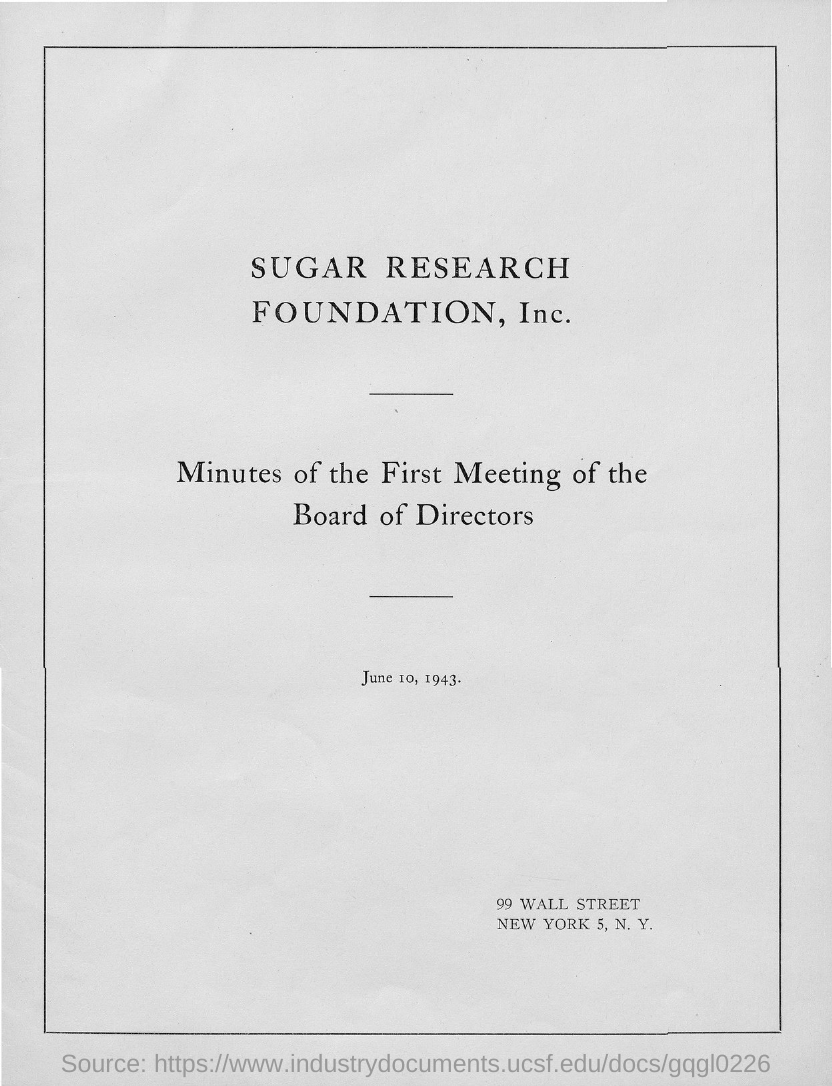What is the name of the foundation given at the top?
Give a very brief answer. Sugar Research Foundation, Inc. What is the second title in this document?
Offer a very short reply. Minutes of the First Meeting of the Board of Directors. Minutes of which meeting is this?
Make the answer very short. First meeting of the board of directors. 